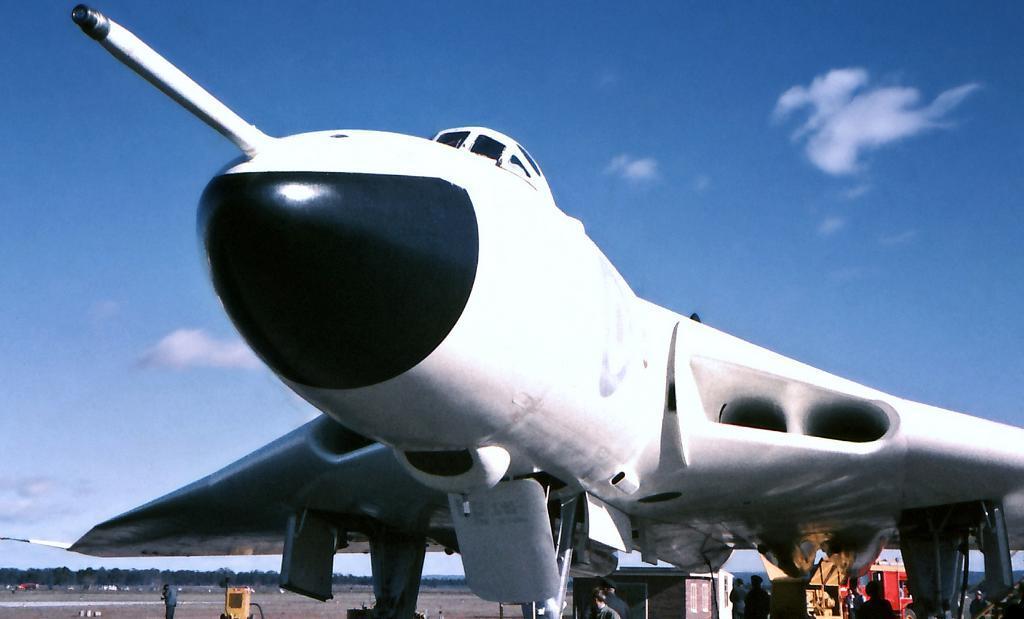Could you give a brief overview of what you see in this image? In this picture I can see an aeroplane and few people standing and I can see a building and a vehicle and I can see trees and a blue cloudy sky. 